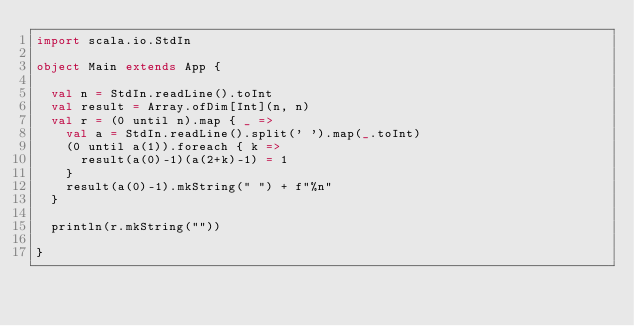<code> <loc_0><loc_0><loc_500><loc_500><_Scala_>import scala.io.StdIn

object Main extends App {
  
  val n = StdIn.readLine().toInt
  val result = Array.ofDim[Int](n, n)
  val r = (0 until n).map { _ =>
    val a = StdIn.readLine().split(' ').map(_.toInt)
    (0 until a(1)).foreach { k =>
      result(a(0)-1)(a(2+k)-1) = 1
    }
    result(a(0)-1).mkString(" ") + f"%n"
  }

  println(r.mkString(""))

}
</code> 